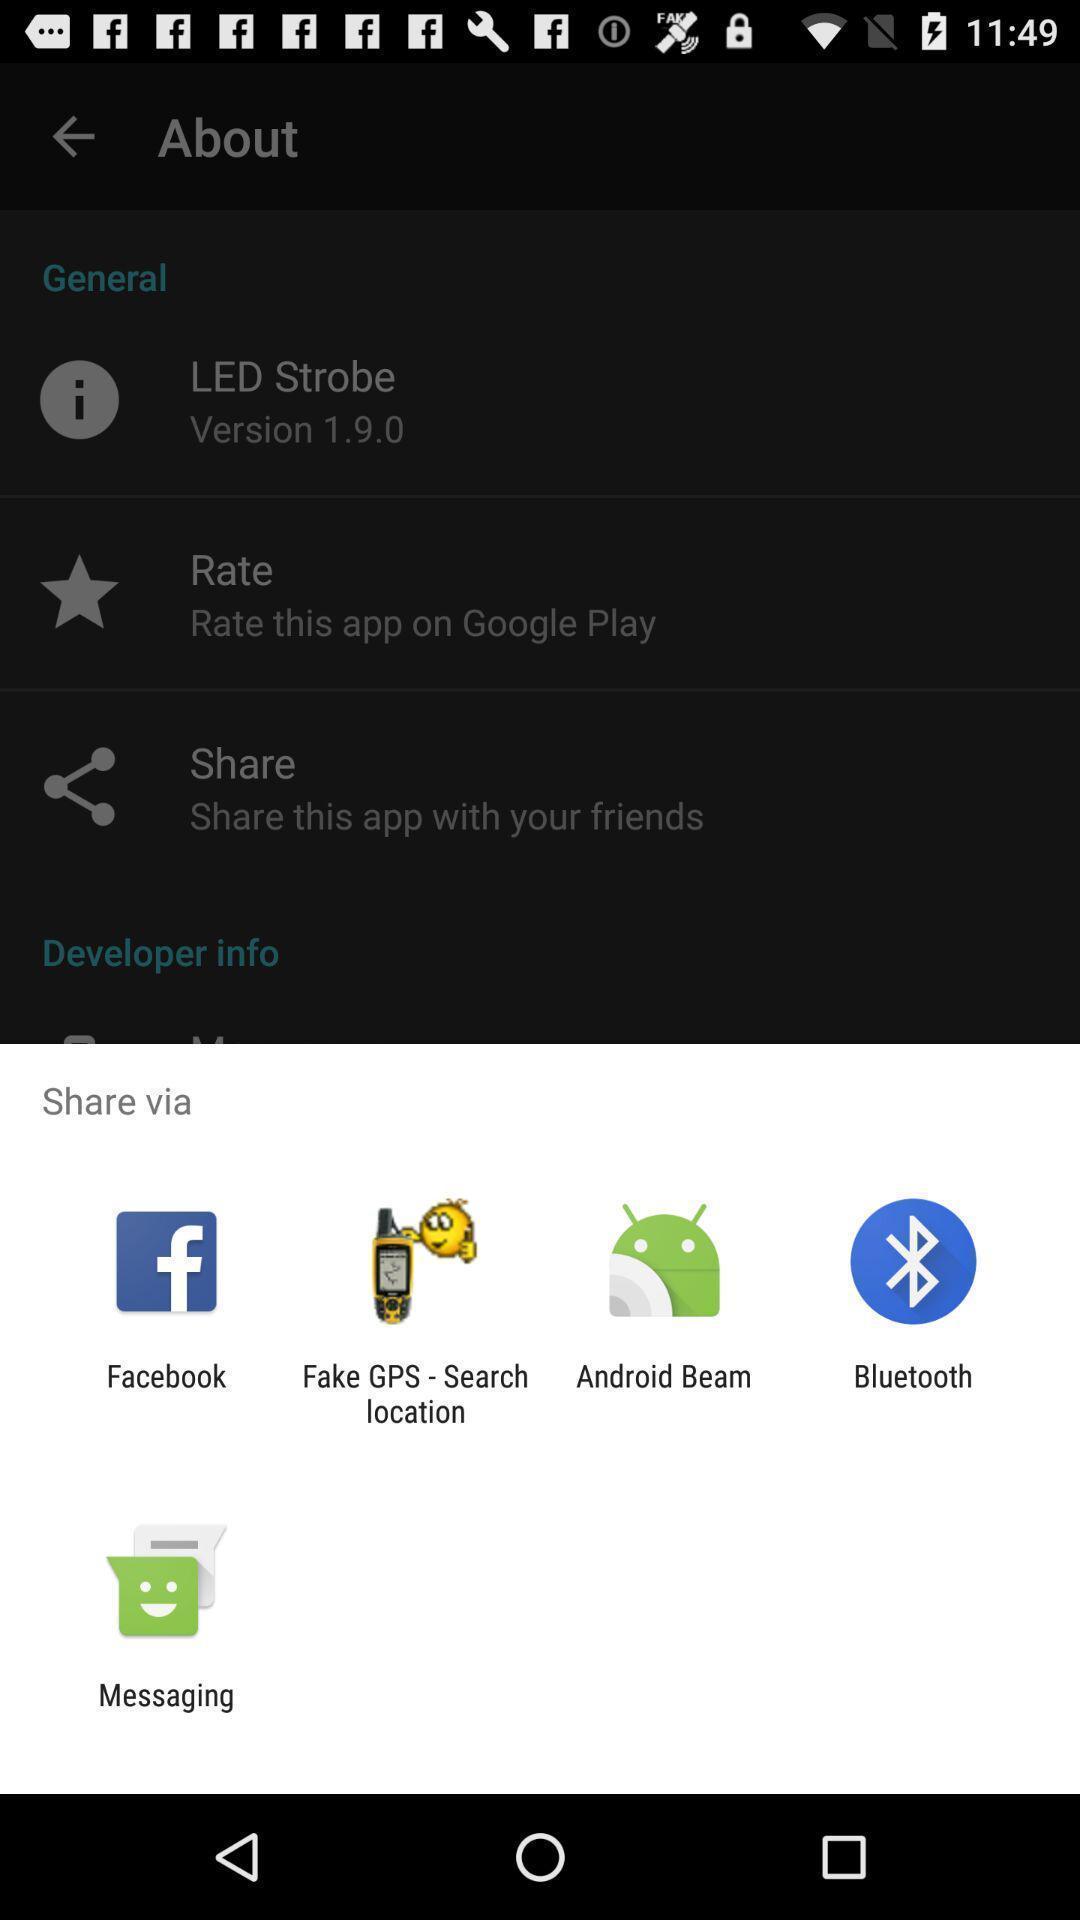Summarize the information in this screenshot. Share information with different apps. 